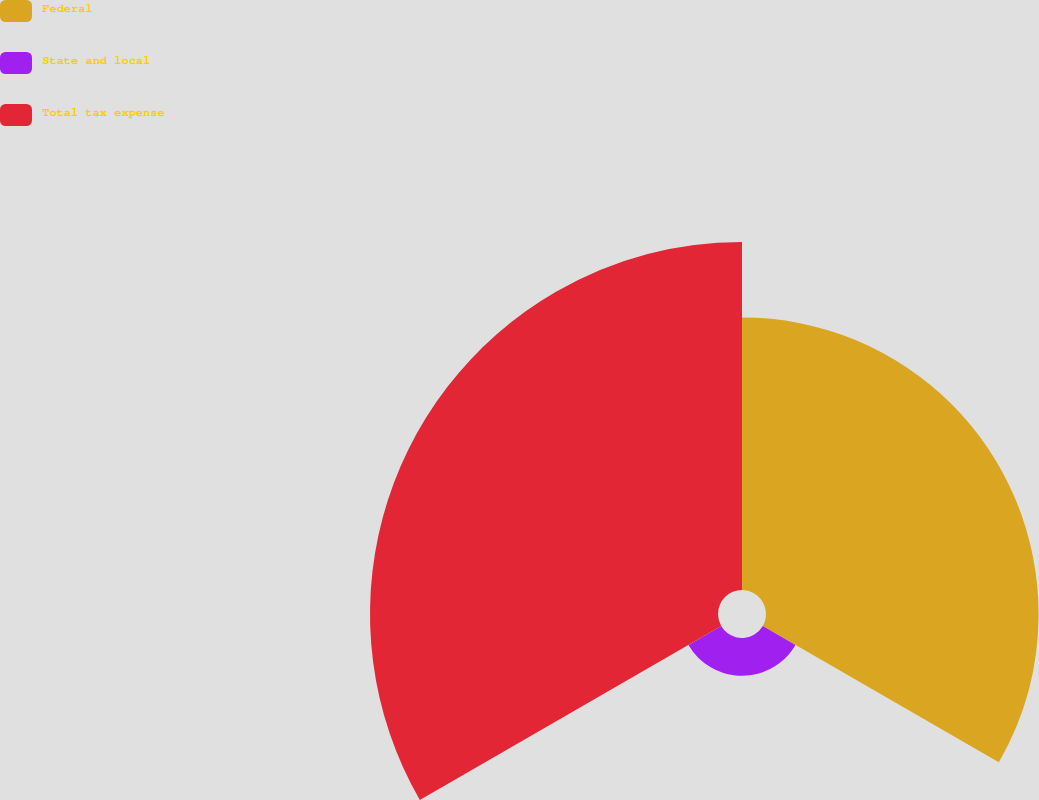Convert chart. <chart><loc_0><loc_0><loc_500><loc_500><pie_chart><fcel>Federal<fcel>State and local<fcel>Total tax expense<nl><fcel>41.4%<fcel>5.74%<fcel>52.86%<nl></chart> 